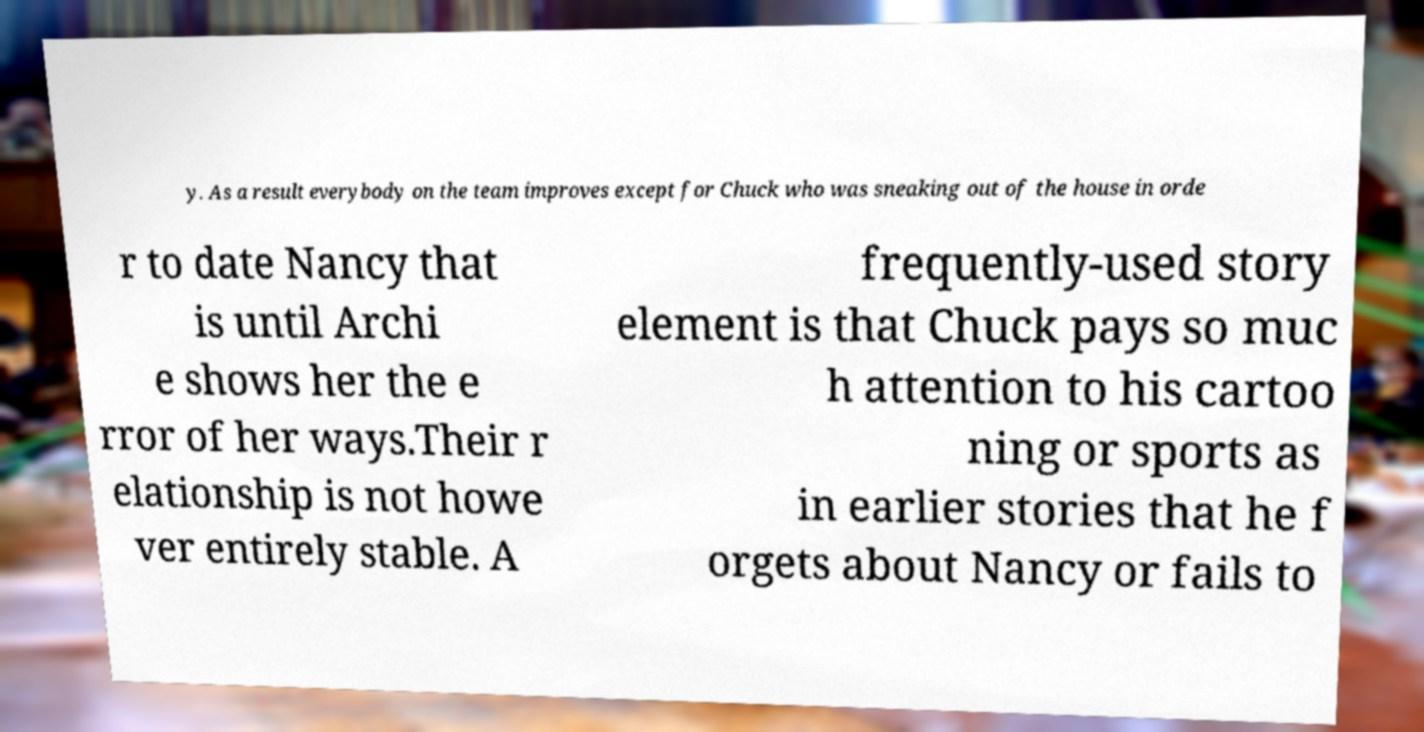Could you assist in decoding the text presented in this image and type it out clearly? y. As a result everybody on the team improves except for Chuck who was sneaking out of the house in orde r to date Nancy that is until Archi e shows her the e rror of her ways.Their r elationship is not howe ver entirely stable. A frequently-used story element is that Chuck pays so muc h attention to his cartoo ning or sports as in earlier stories that he f orgets about Nancy or fails to 